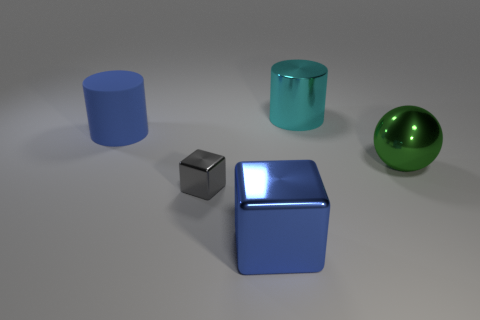Are there any tiny gray metallic cylinders?
Offer a very short reply. No. There is a matte cylinder that is the same size as the metallic cylinder; what is its color?
Offer a terse response. Blue. What number of blue things have the same shape as the cyan thing?
Offer a very short reply. 1. Do the cube in front of the small gray metallic block and the green ball have the same material?
Provide a succinct answer. Yes. How many cylinders are rubber things or red matte objects?
Offer a very short reply. 1. There is a big blue thing that is behind the large blue object that is in front of the large blue matte cylinder behind the big green sphere; what shape is it?
Provide a succinct answer. Cylinder. There is a large rubber thing that is the same color as the big block; what is its shape?
Your answer should be very brief. Cylinder. What number of other metal things have the same size as the blue shiny thing?
Offer a terse response. 2. Is there a big blue object behind the large blue object that is in front of the metallic sphere?
Your answer should be compact. Yes. What number of things are large cyan objects or large gray rubber balls?
Make the answer very short. 1. 